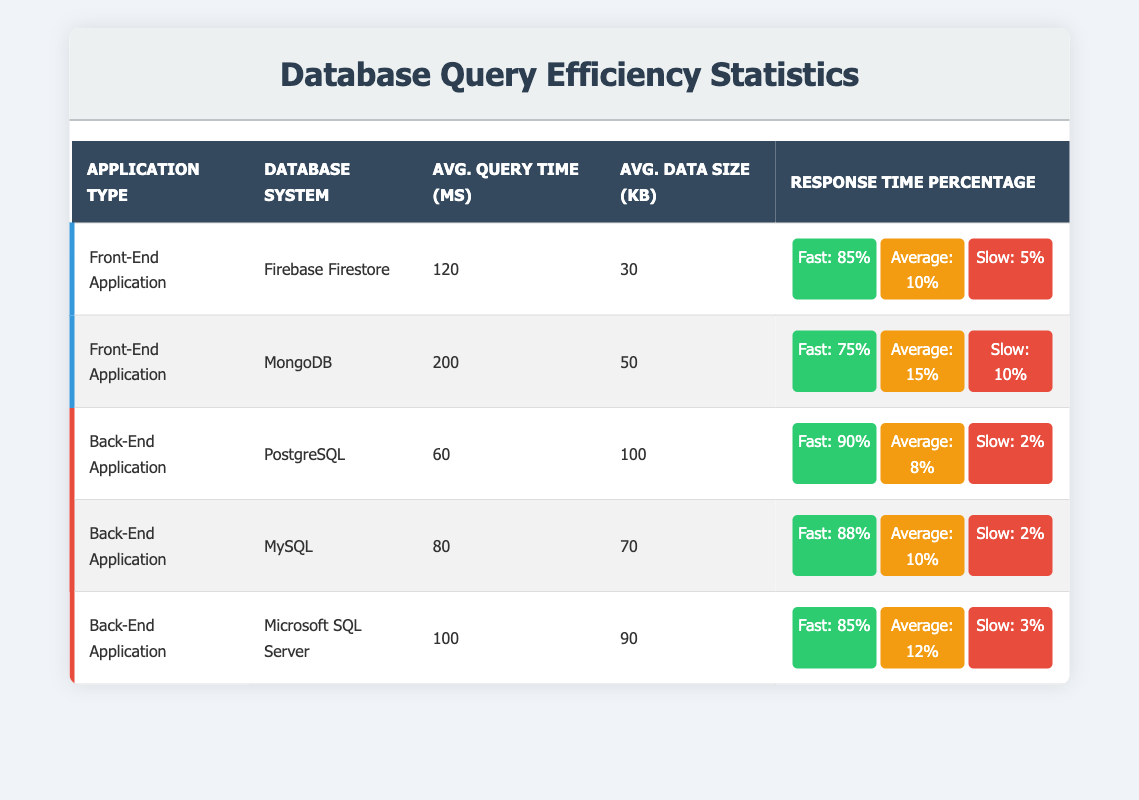What is the average query time for Front-End applications? The average query time for the Front-End applications can be calculated by taking the average of the individual query times from both Firebase Firestore (120 ms) and MongoDB (200 ms): (120 + 200) / 2 = 160 ms.
Answer: 160 ms Which Back-End application has the fastest average query time? From the table, we can see the average query times for Back-End applications: PostgreSQL (60 ms), MySQL (80 ms), and Microsoft SQL Server (100 ms). The lowest value is for PostgreSQL, so it has the fastest average query time.
Answer: PostgreSQL What percentage of queries in MongoDB are classified as fast? Referring to the table, MongoDB has a response time percentage of 75% classified as fast.
Answer: 75% What is the average data size for Back-End applications? The average data size for Back-End applications can be calculated by taking the average of the individual average data sizes from PostgreSQL (100 KB), MySQL (70 KB), and Microsoft SQL Server (90 KB): (100 + 70 + 90) / 3 = 86.67 KB.
Answer: 86.67 KB Is the average query time for Back-End applications lower than that for Front-End applications? The average query time for Back-End applications is (60 + 80 + 100) / 3 = 80 ms. For Front-End applications, it is 160 ms. Since 80 is lower than 160, the average query time for Back-End applications is indeed lower.
Answer: Yes What is the slowest application in terms of query response time? The slowest application can be identified by looking for the highest percentage in the slow response time category. Firebase Firestore has a slow percentage of 5%, MongoDB has 10%, while Back-End applications have 2% for PostgreSQL, 2% for MySQL, and 3% for Microsoft SQL Server. Thus, MongoDB is the slowest.
Answer: MongoDB How many applications have an average query time of less than 100 ms? Checking the average query times: PostgreSQL (60 ms), MySQL (80 ms), and Firebase Firestore (120 ms) are below 100 ms. Therefore, there are 3 applications with an average query time of less than 100 ms.
Answer: 3 Which database system offers the best response time percentage for fast queries in Back-End applications? In Back-End applications, PostgreSQL has a fast query response percentage of 90%, which is higher than MySQL's 88% and Microsoft SQL Server's 85%. Therefore, PostgreSQL offers the best response time percentage for fast queries in Back-End applications.
Answer: PostgreSQL 